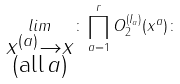Convert formula to latex. <formula><loc_0><loc_0><loc_500><loc_500>\underset { \substack { x ^ { ( a ) } \rightarrow x \\ ( \text {all} \, a ) } } { l i m } \colon \prod _ { a = 1 } ^ { r } O _ { 2 } ^ { ( I _ { a } ) } ( x ^ { a } ) \colon</formula> 